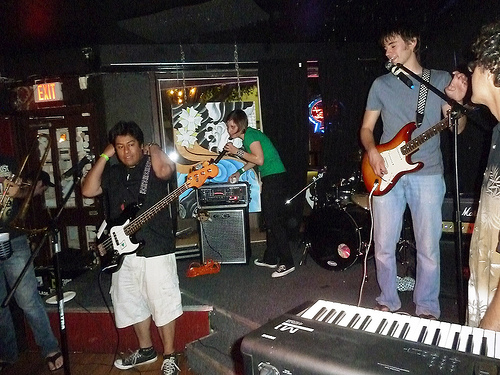<image>
Is the girl to the left of the boy? Yes. From this viewpoint, the girl is positioned to the left side relative to the boy. 